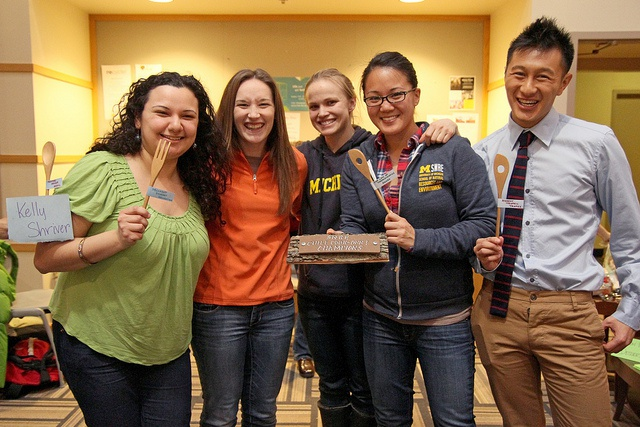Describe the objects in this image and their specific colors. I can see people in tan, darkgray, maroon, lightgray, and black tones, people in tan, black, olive, and maroon tones, people in tan, black, gray, and brown tones, people in tan, black, red, brown, and maroon tones, and people in tan, black, maroon, and brown tones in this image. 